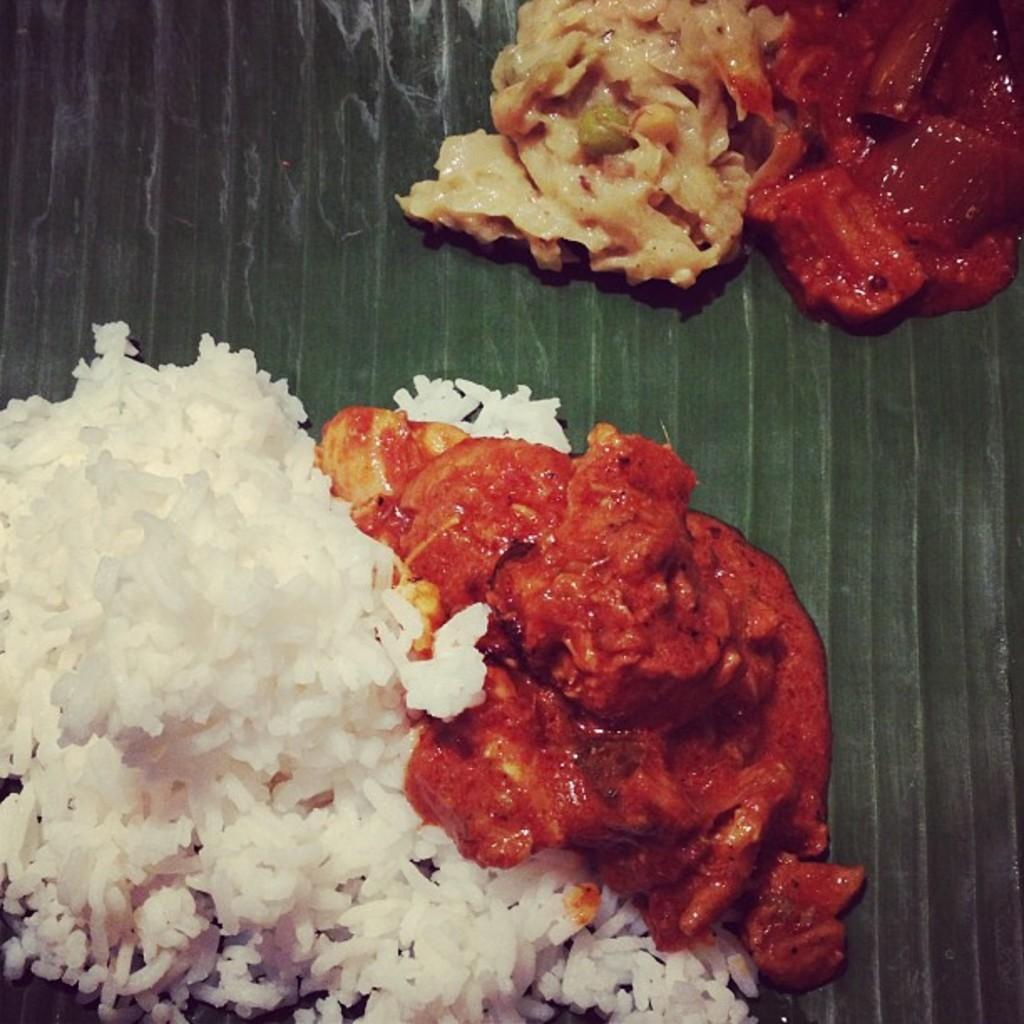What type of food is present in the image? There is rice and curry in the image. Are there any other food items visible? Yes, there are other food items in the image. How are the food items arranged or presented? The food items are kept on a leaf. What type of tax is being discussed in the image? There is no mention of tax or any discussion in the image; it features food items on a leaf. What kind of amusement can be seen in the image? There is no amusement present in the image; it only contains food items on a leaf. 